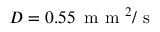Convert formula to latex. <formula><loc_0><loc_0><loc_500><loc_500>D = 0 . 5 5 \, m m ^ { 2 } / s</formula> 